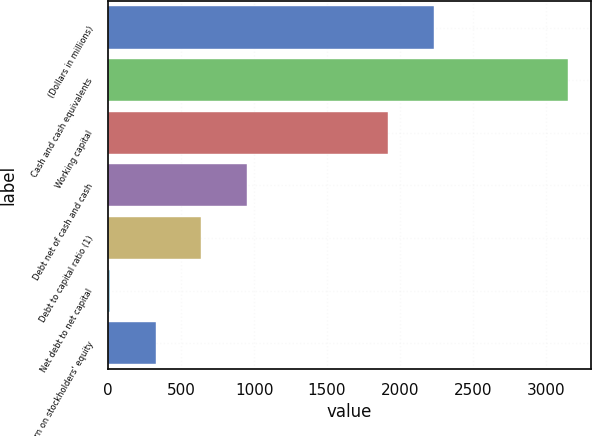Convert chart. <chart><loc_0><loc_0><loc_500><loc_500><bar_chart><fcel>(Dollars in millions)<fcel>Cash and cash equivalents<fcel>Working capital<fcel>Debt net of cash and cash<fcel>Debt to capital ratio (1)<fcel>Net debt to net capital<fcel>Return on stockholders' equity<nl><fcel>2230.82<fcel>3149<fcel>1917<fcel>952.26<fcel>638.44<fcel>10.8<fcel>324.62<nl></chart> 